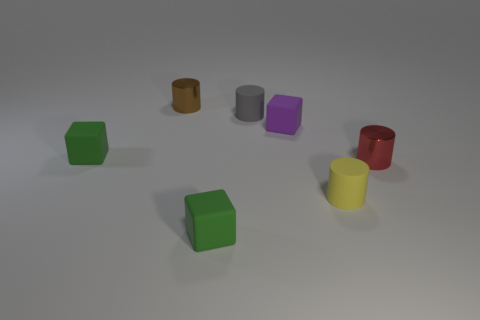Is the number of tiny things behind the brown metal thing less than the number of small green blocks that are in front of the yellow thing?
Give a very brief answer. Yes. The cylinder on the left side of the small gray rubber cylinder is what color?
Your answer should be compact. Brown. There is a small red metallic object; how many small objects are behind it?
Keep it short and to the point. 4. Is there a yellow matte cylinder of the same size as the yellow matte thing?
Your answer should be compact. No. What color is the tiny object that is in front of the small matte cylinder on the right side of the purple rubber object?
Keep it short and to the point. Green. How many objects are both on the left side of the small gray cylinder and in front of the brown cylinder?
Provide a short and direct response. 2. How many other red things have the same shape as the small red metallic object?
Your response must be concise. 0. Is the purple object made of the same material as the tiny yellow cylinder?
Keep it short and to the point. Yes. There is a small green rubber thing right of the shiny cylinder on the left side of the tiny purple block; what shape is it?
Make the answer very short. Cube. What number of things are to the right of the block that is in front of the red metallic cylinder?
Make the answer very short. 4. 